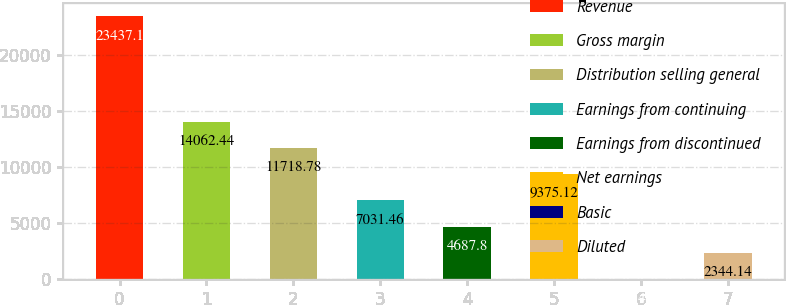Convert chart. <chart><loc_0><loc_0><loc_500><loc_500><bar_chart><fcel>Revenue<fcel>Gross margin<fcel>Distribution selling general<fcel>Earnings from continuing<fcel>Earnings from discontinued<fcel>Net earnings<fcel>Basic<fcel>Diluted<nl><fcel>23437.1<fcel>14062.4<fcel>11718.8<fcel>7031.46<fcel>4687.8<fcel>9375.12<fcel>0.48<fcel>2344.14<nl></chart> 